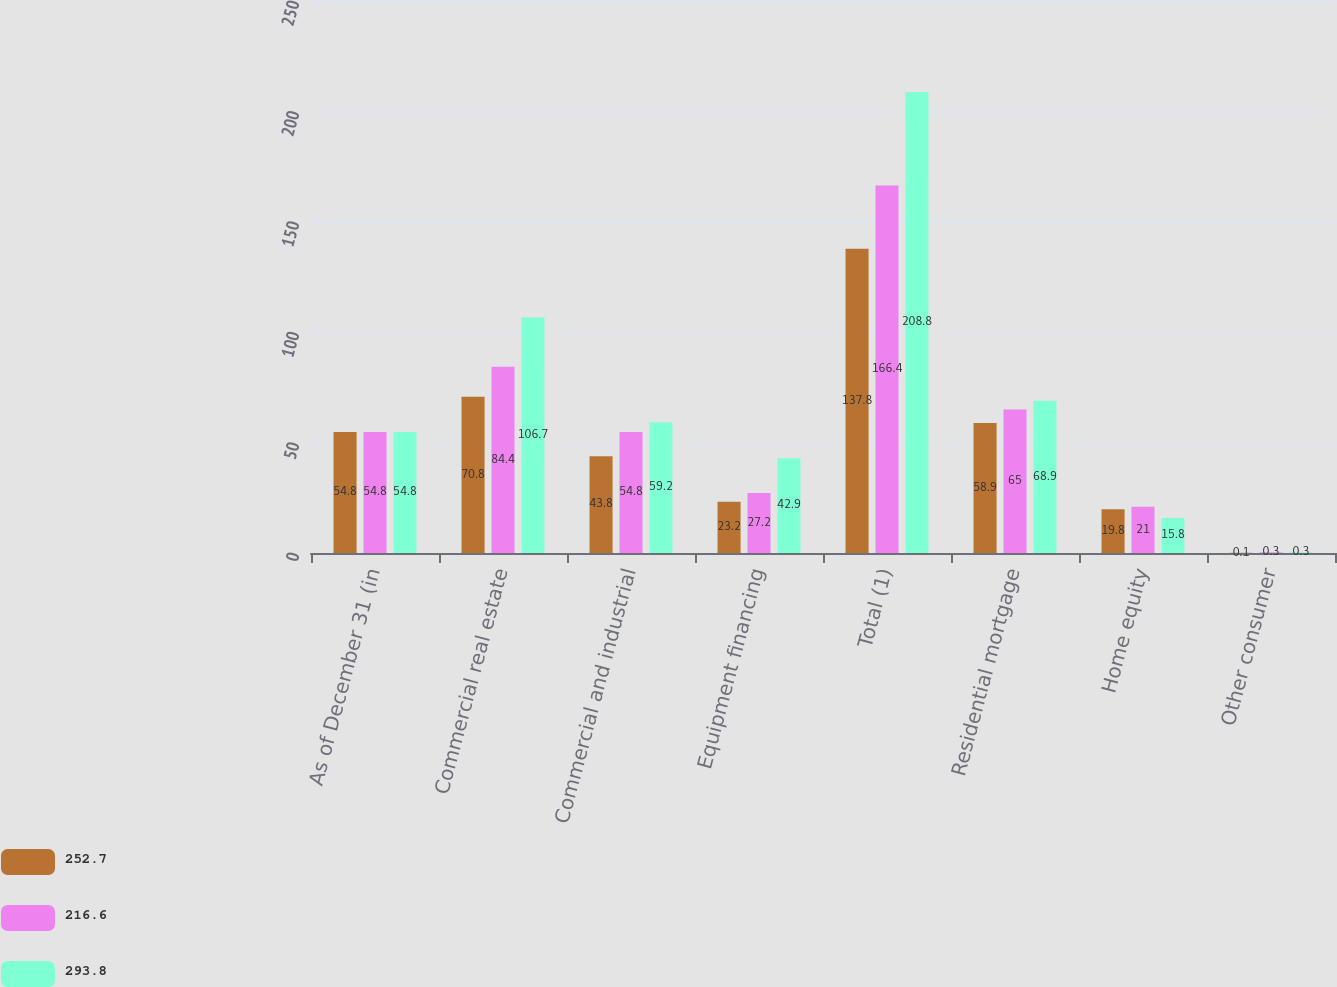Convert chart. <chart><loc_0><loc_0><loc_500><loc_500><stacked_bar_chart><ecel><fcel>As of December 31 (in<fcel>Commercial real estate<fcel>Commercial and industrial<fcel>Equipment financing<fcel>Total (1)<fcel>Residential mortgage<fcel>Home equity<fcel>Other consumer<nl><fcel>252.7<fcel>54.8<fcel>70.8<fcel>43.8<fcel>23.2<fcel>137.8<fcel>58.9<fcel>19.8<fcel>0.1<nl><fcel>216.6<fcel>54.8<fcel>84.4<fcel>54.8<fcel>27.2<fcel>166.4<fcel>65<fcel>21<fcel>0.3<nl><fcel>293.8<fcel>54.8<fcel>106.7<fcel>59.2<fcel>42.9<fcel>208.8<fcel>68.9<fcel>15.8<fcel>0.3<nl></chart> 